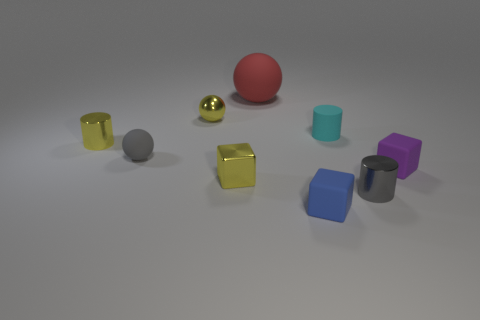Subtract all metal cubes. How many cubes are left? 2 Subtract all cylinders. How many objects are left? 6 Subtract all cyan balls. Subtract all green cylinders. How many balls are left? 3 Add 5 small metallic objects. How many small metallic objects are left? 9 Add 9 tiny gray spheres. How many tiny gray spheres exist? 10 Subtract 1 yellow balls. How many objects are left? 8 Subtract all big green matte objects. Subtract all tiny gray cylinders. How many objects are left? 8 